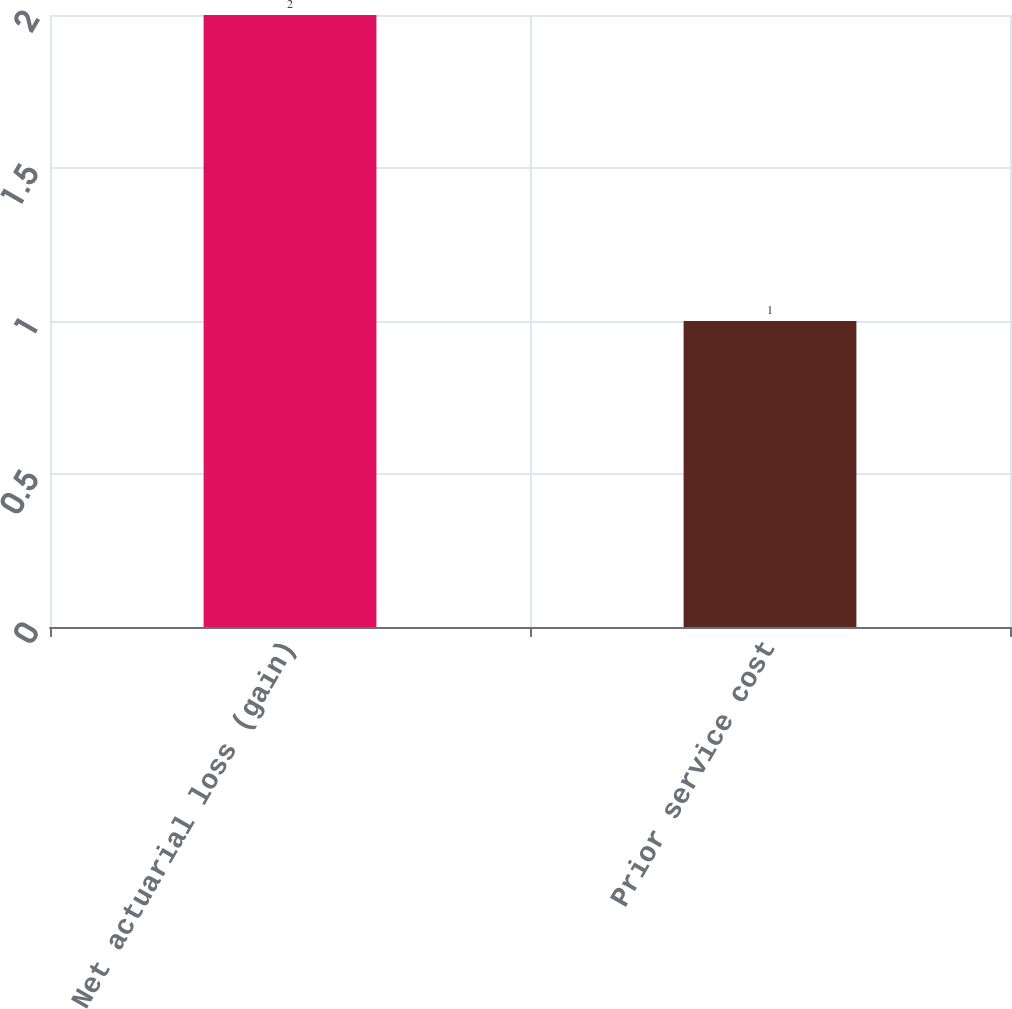Convert chart to OTSL. <chart><loc_0><loc_0><loc_500><loc_500><bar_chart><fcel>Net actuarial loss (gain)<fcel>Prior service cost<nl><fcel>2<fcel>1<nl></chart> 